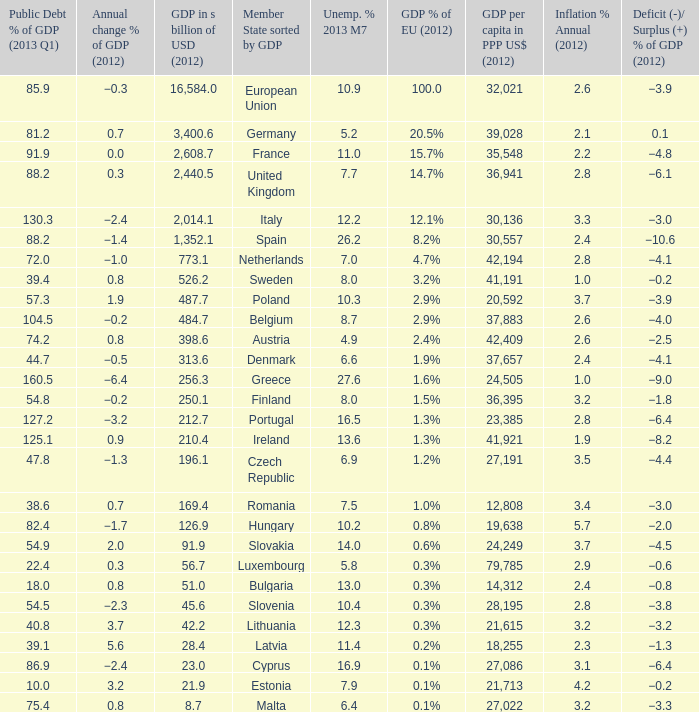For a country that is part of a member None. 